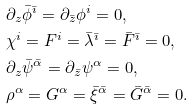Convert formula to latex. <formula><loc_0><loc_0><loc_500><loc_500>& \partial _ { z } \bar { \phi } ^ { \bar { \imath } } = \partial _ { \bar { z } } \phi ^ { i } = 0 , \\ & \chi ^ { i } = F ^ { i } = \bar { \lambda } ^ { \bar { \imath } } = \bar { F } ^ { \bar { \imath } } = 0 , \\ & \partial _ { z } \bar { \psi } ^ { \bar { \alpha } } = \partial _ { \bar { z } } \psi ^ { \alpha } = 0 , \\ & \rho ^ { \alpha } = G ^ { \alpha } = \bar { \xi } ^ { \bar { \alpha } } = \bar { G } ^ { \bar { \alpha } } = 0 .</formula> 